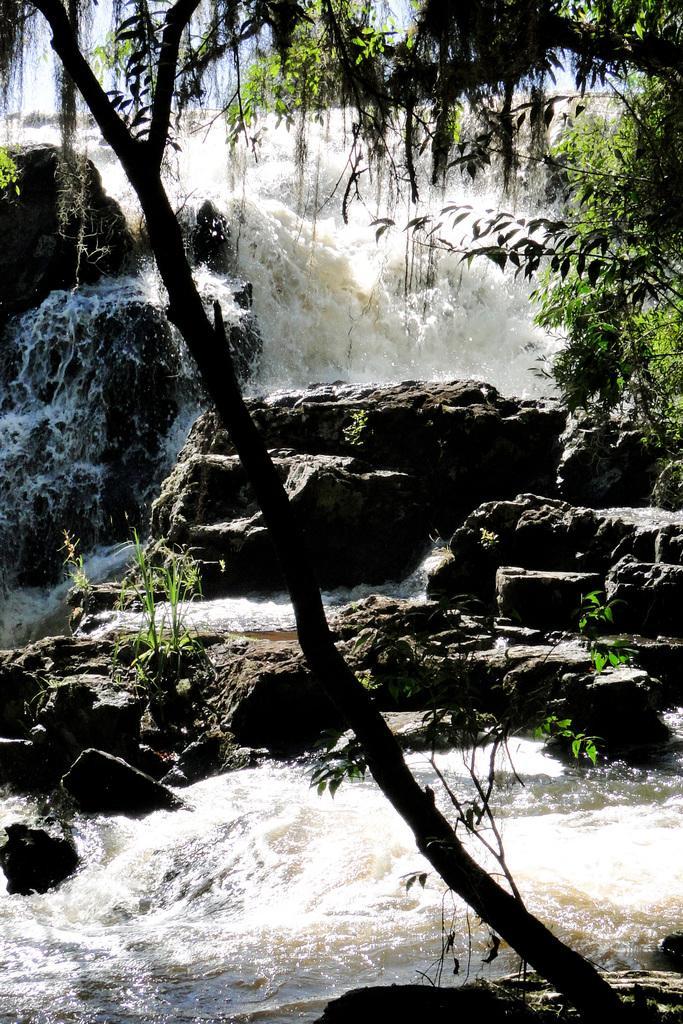Describe this image in one or two sentences. In this image I can see trees and a waterfall on the mountains. At the top I can see the sky. This image is taken during a day. 